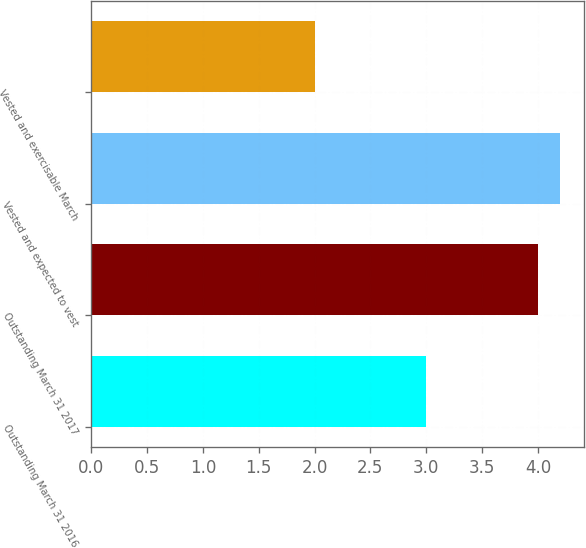Convert chart. <chart><loc_0><loc_0><loc_500><loc_500><bar_chart><fcel>Outstanding March 31 2016<fcel>Outstanding March 31 2017<fcel>Vested and expected to vest<fcel>Vested and exercisable March<nl><fcel>3<fcel>4<fcel>4.2<fcel>2<nl></chart> 